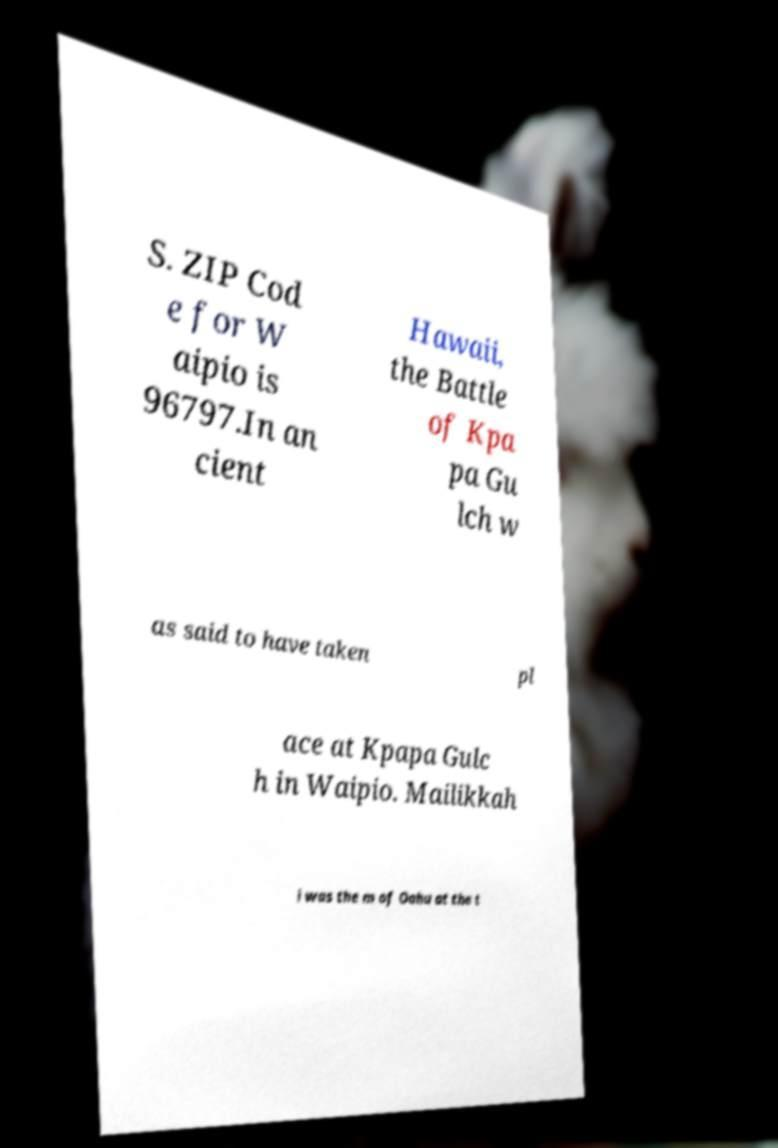Could you assist in decoding the text presented in this image and type it out clearly? S. ZIP Cod e for W aipio is 96797.In an cient Hawaii, the Battle of Kpa pa Gu lch w as said to have taken pl ace at Kpapa Gulc h in Waipio. Mailikkah i was the m of Oahu at the t 